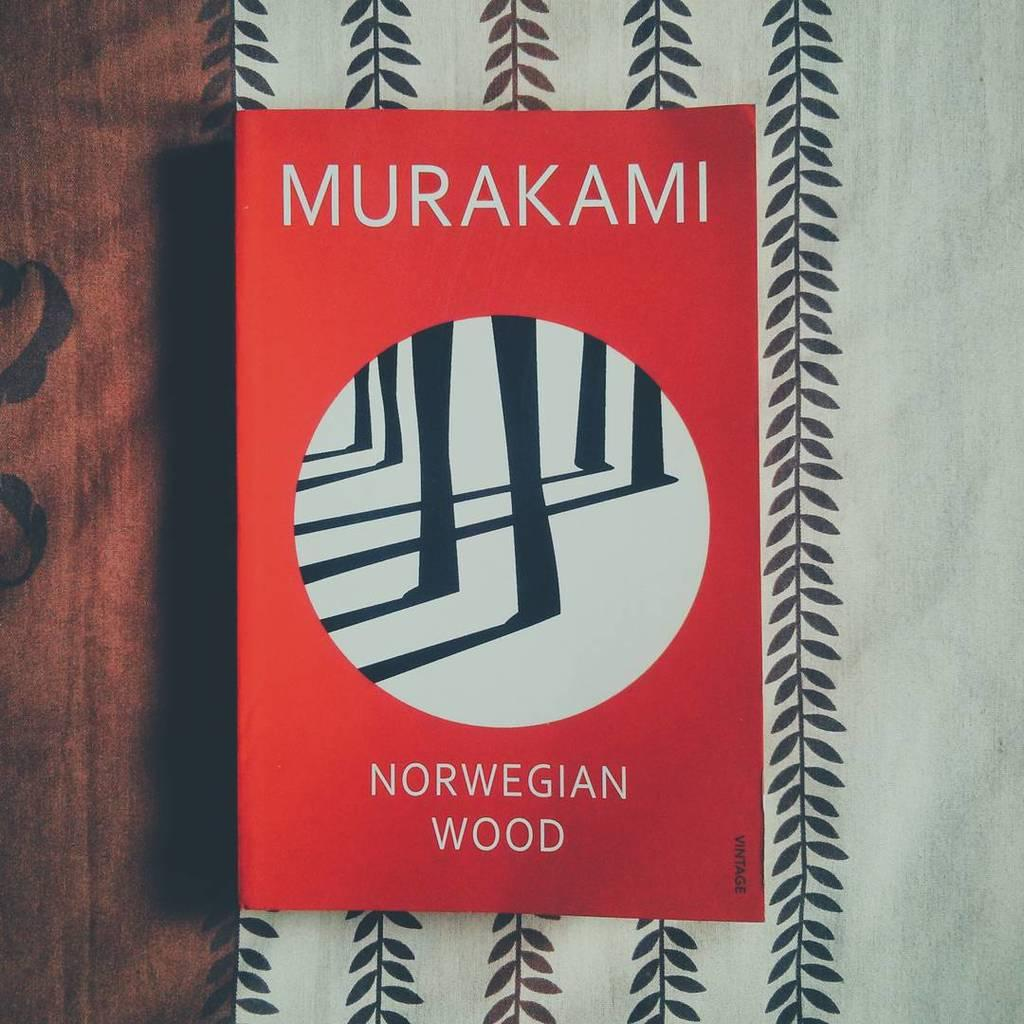Provide a one-sentence caption for the provided image. A red book by Murakami sits on top of some black and white fabric. 